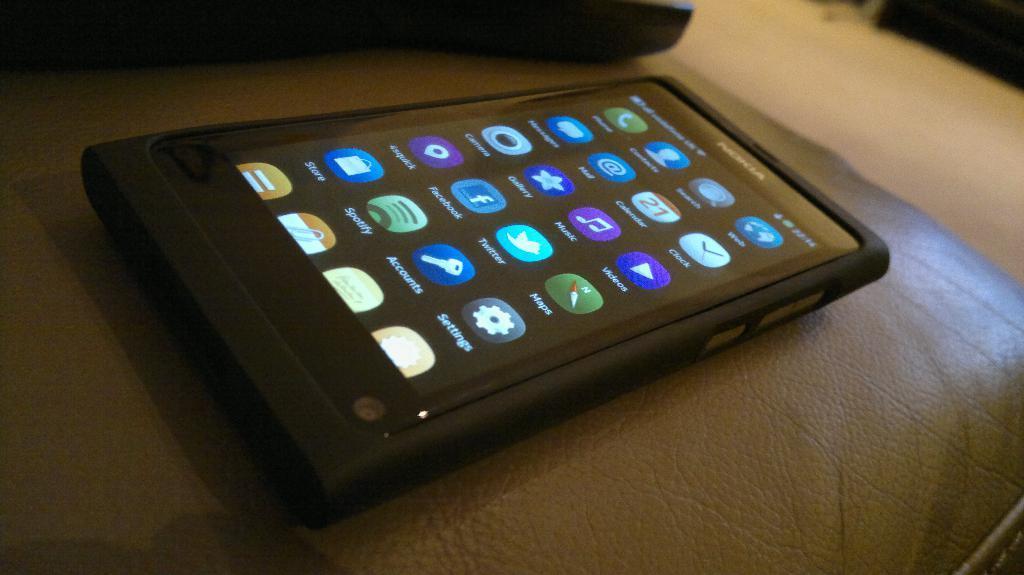Please provide a concise description of this image. In the image we can see a mobile phone, on a sofa. This is a screen of the device. 